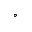Convert formula to latex. <formula><loc_0><loc_0><loc_500><loc_500>^ { \circ }</formula> 